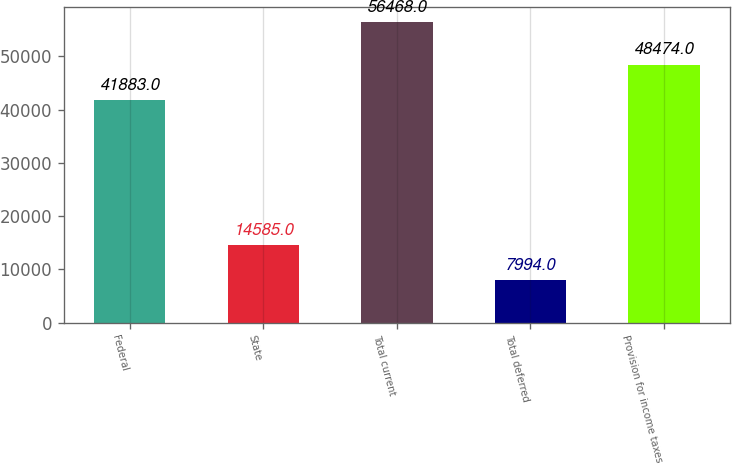Convert chart to OTSL. <chart><loc_0><loc_0><loc_500><loc_500><bar_chart><fcel>Federal<fcel>State<fcel>Total current<fcel>Total deferred<fcel>Provision for income taxes<nl><fcel>41883<fcel>14585<fcel>56468<fcel>7994<fcel>48474<nl></chart> 